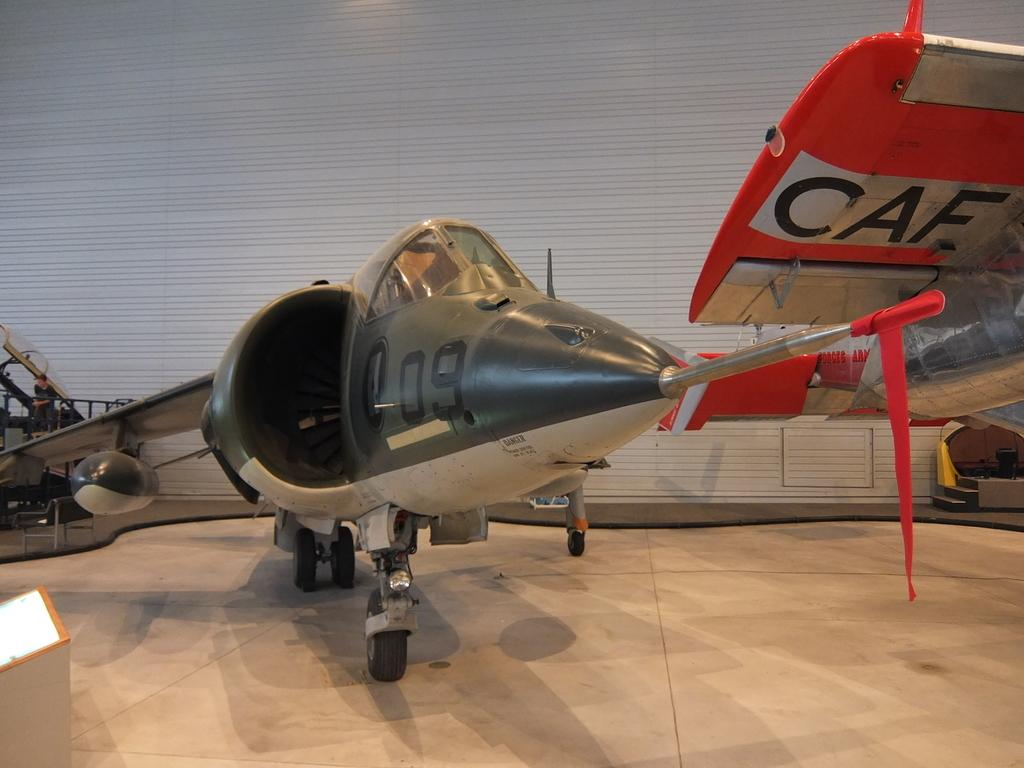<image>
Provide a brief description of the given image. a plane with the number 09 on it 